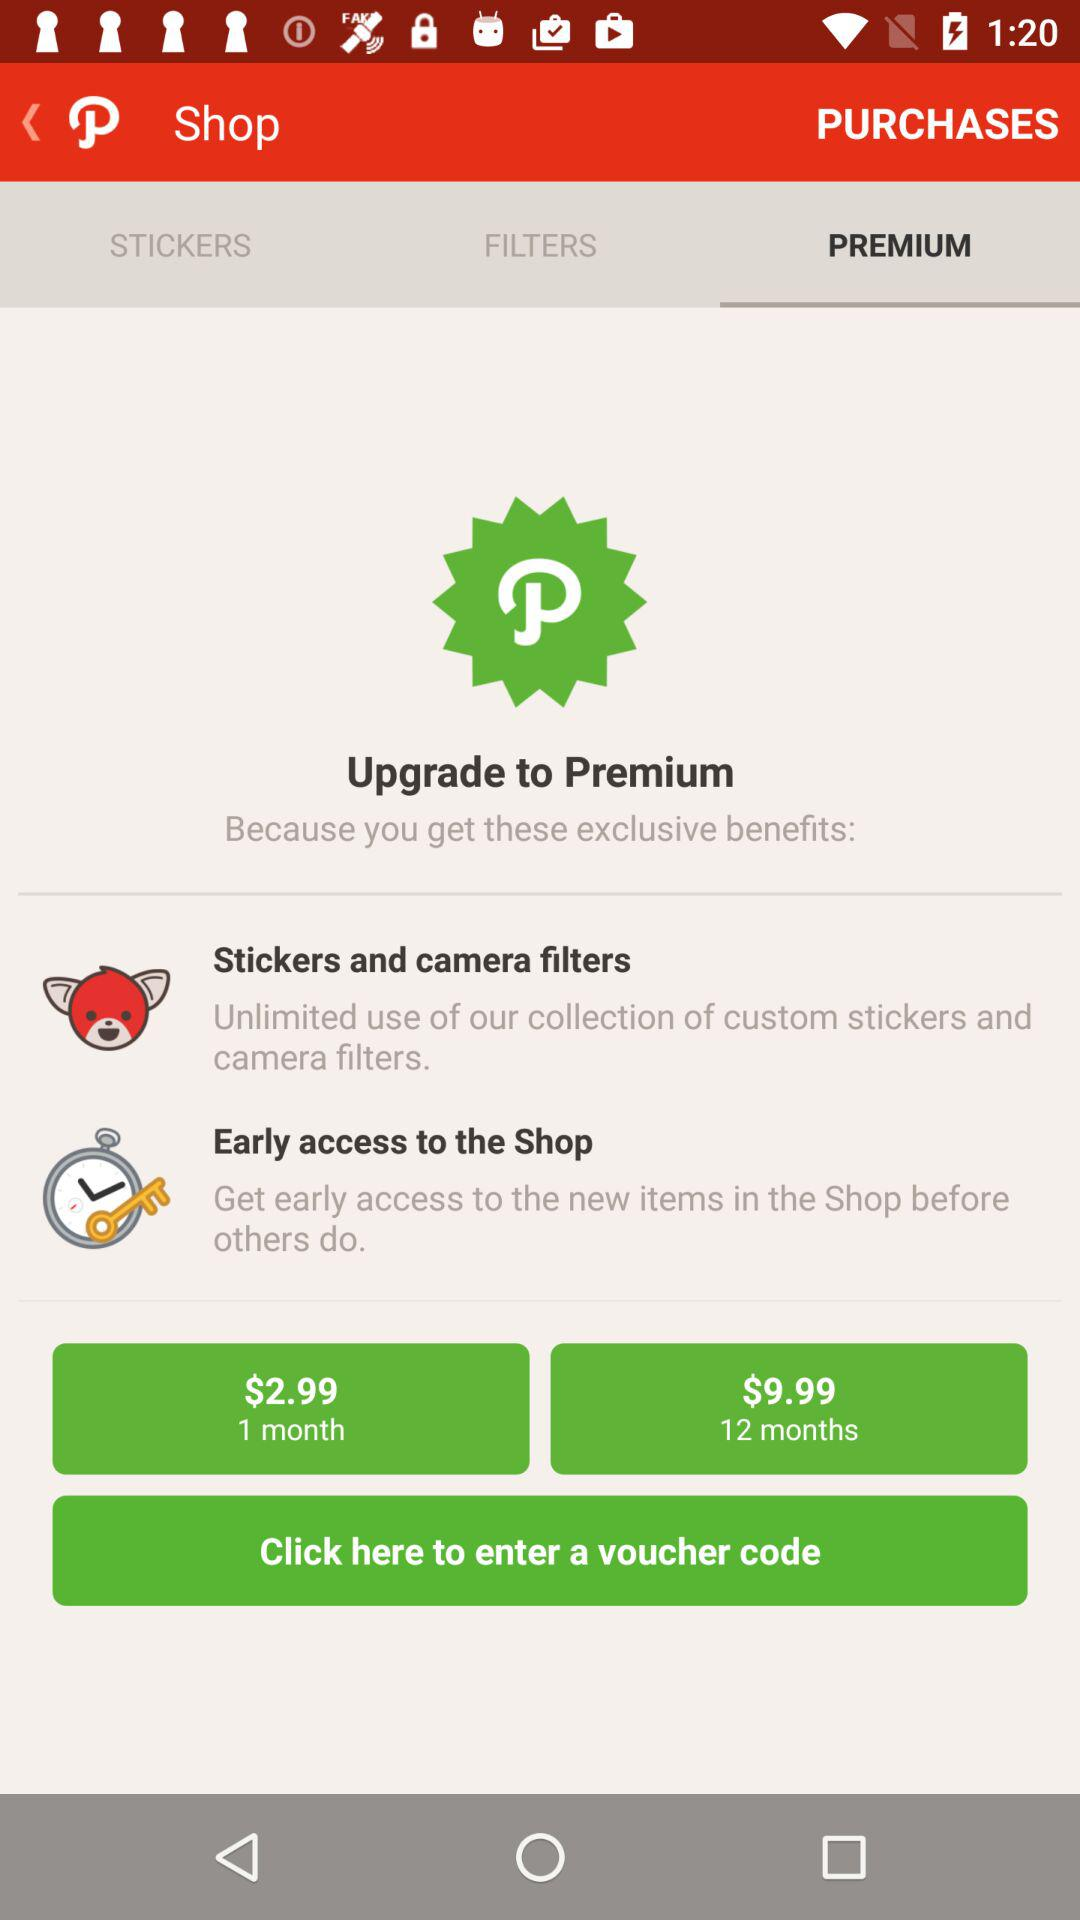Which tab is currently selected? The currently selected tab is "PREMIUM". 